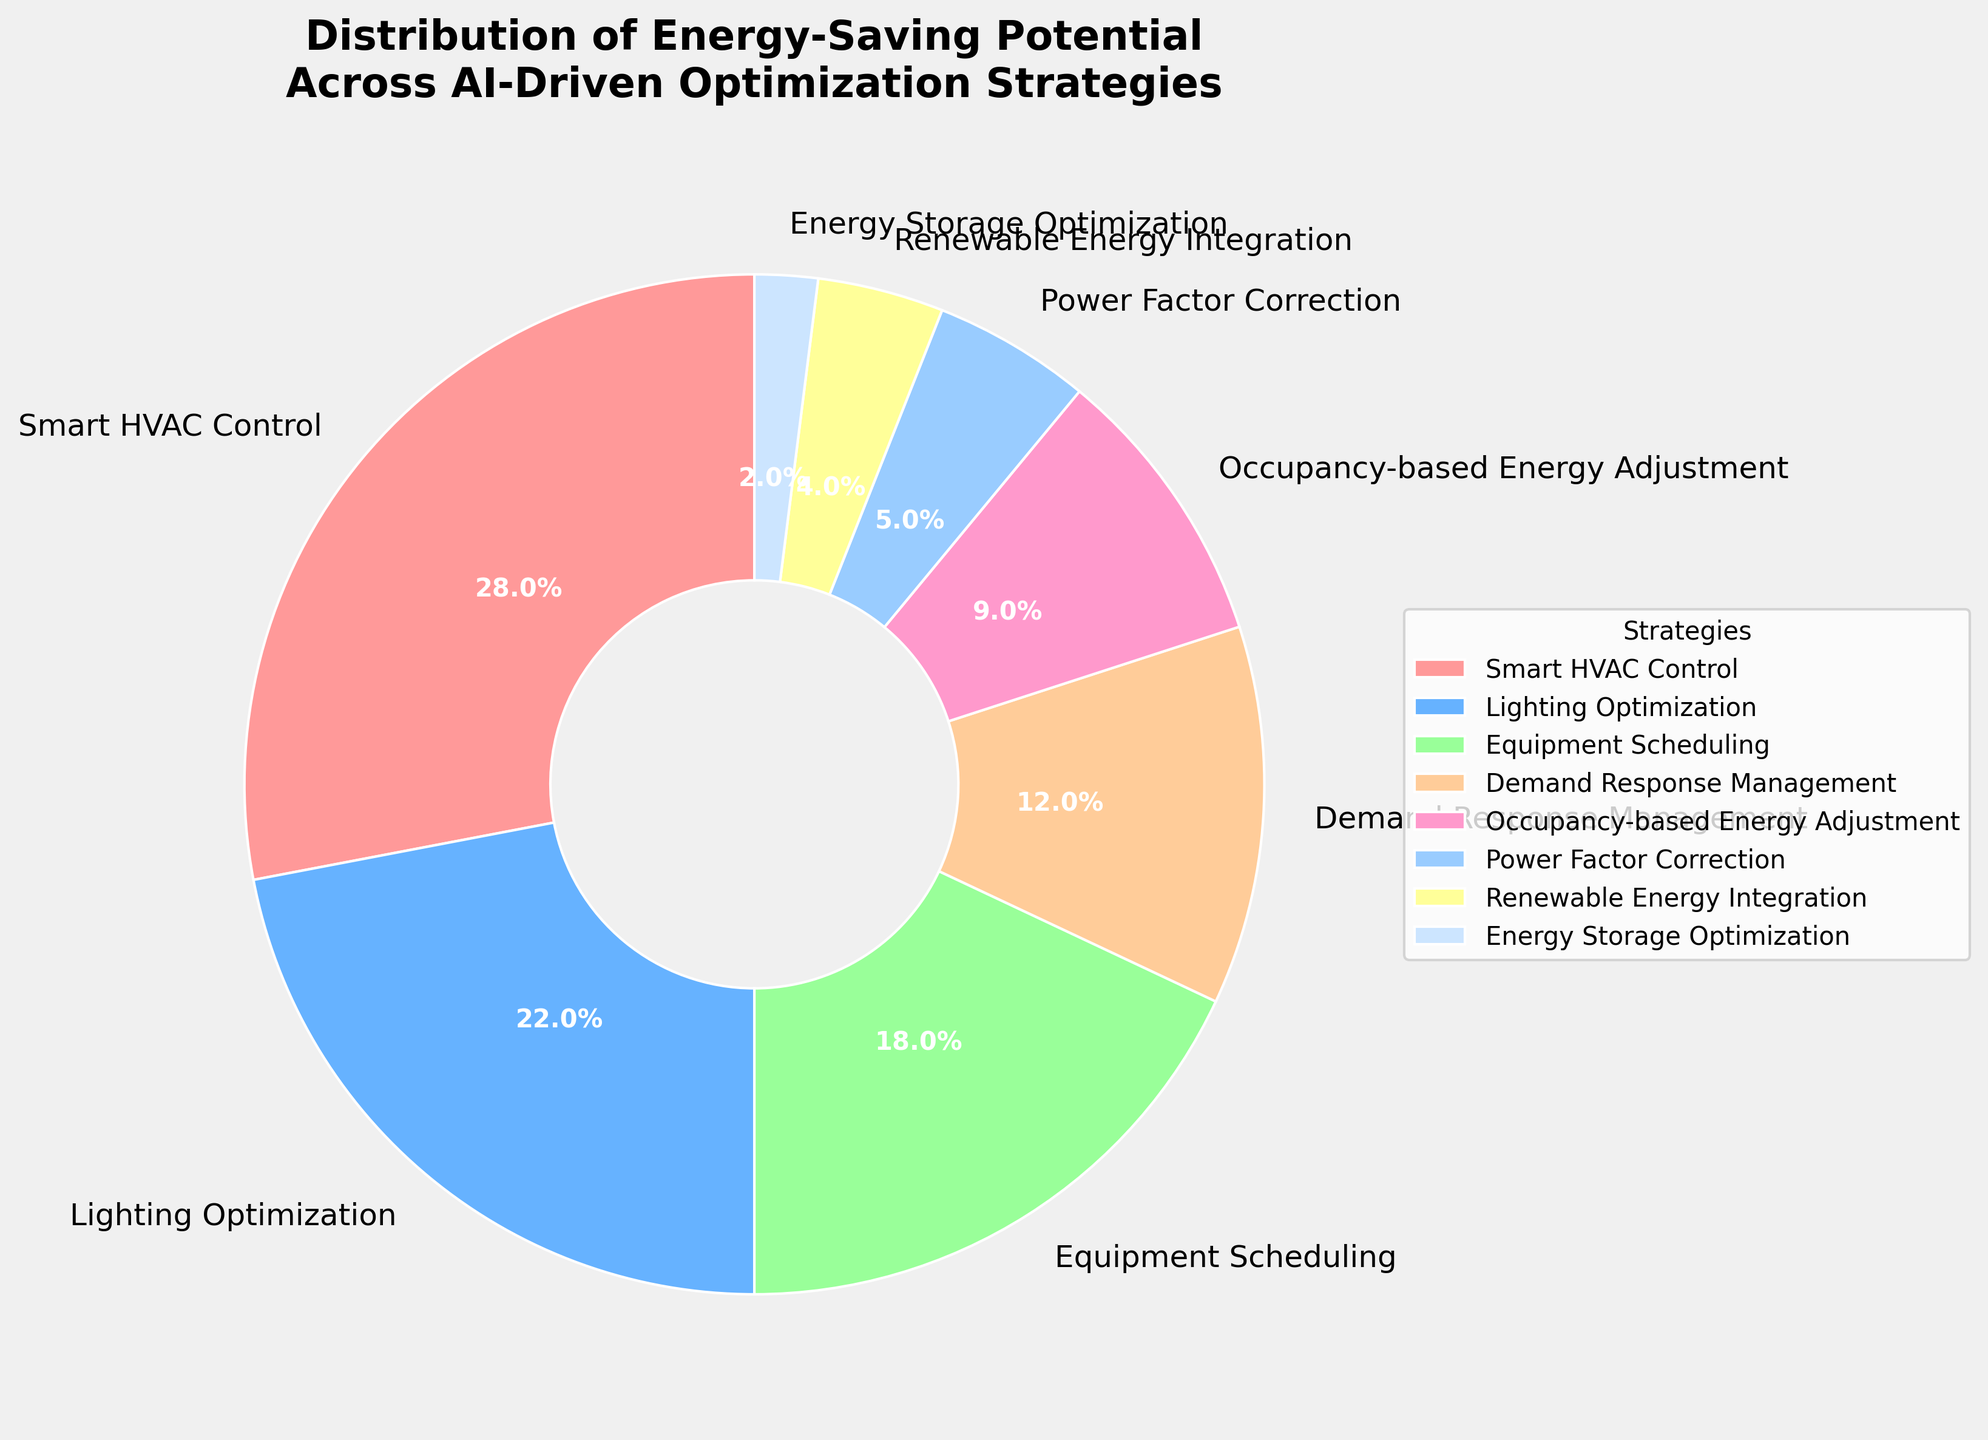What is the strategy with the highest energy-saving potential? The strategy with the highest percentage on the pie chart will have the largest wedge visually. By examining the sizes of the wedges and the labels, we see that Smart HVAC Control has the largest portion.
Answer: Smart HVAC Control Which strategies collectively contribute to more than 50% of the energy-saving potential? To answer this, sum the percentages of the largest wedges until the total exceeds 50%. Smart HVAC Control (28%), Lighting Optimization (22%), and Equipment Scheduling (18%) together make up 68%.
Answer: Smart HVAC Control, Lighting Optimization, Equipment Scheduling How much more potential does Smart HVAC Control have compared to Power Factor Correction? Subtract the percentage of Power Factor Correction from Smart HVAC Control. Smart HVAC Control is 28% and Power Factor Correction is 5%, so the difference is 28 - 5 = 23%.
Answer: 23% Which strategies have a potential of less than 10%? Identify the wedges in the pie chart that are labeled with less than 10% each. Occupancy-based Energy Adjustment (9%), Power Factor Correction (5%), Renewable Energy Integration (4%), and Energy Storage Optimization (2%) all fall within this range.
Answer: Occupancy-based Energy Adjustment, Power Factor Correction, Renewable Energy Integration, Energy Storage Optimization What is the combined percentage for Renewable Energy Integration and Energy Storage Optimization? Add the percentages for Renewable Energy Integration and Energy Storage Optimization. Renewable Energy Integration is 4% and Energy Storage Optimization is 2%, thus 4 + 2 = 6%.
Answer: 6% How does Lighting Optimization compare in energy-saving potential to Demand Response Management? The percentage for Lighting Optimization and Demand Response Management needs to be directly compared. Lighting Optimization is 22% and Demand Response Management is 12%, hence Lighting Optimization has a higher potential.
Answer: Lighting Optimization has a higher potential What portion of the strategies have an energy-saving potential greater than Equipment Scheduling? First, determine the percentage of Equipment Scheduling, which is 18%. Then identify the strategies with percentages greater than 18%. Smart HVAC Control (28%) and Lighting Optimization (22%) both qualify.
Answer: Two strategies What is the total energy-saving potential for all strategies except Smart HVAC Control and Lighting Optimization? Subtract the sum of Smart HVAC Control and Lighting Optimization's percentages from 100%. Smart HVAC Control (28%) + Lighting Optimization (22%) = 50%. Thus, 100% - 50% = 50% remaining for the other strategies.
Answer: 50% Is the potential of Demand Response Management closer to Equipment Scheduling or Occupancy-based Energy Adjustment? Calculate the difference between Demand Response Management and Equipment Scheduling, and then with Occupancy-based Energy Adjustment. Demand Response Management is 12%, Equipment Scheduling is 18%, and Occupancy-based Energy Adjustment is 9%. The differences are 6% and 3%, respectively. Demand Response Management is closer to Occupancy-based Energy Adjustment.
Answer: Occupancy-based Energy Adjustment 